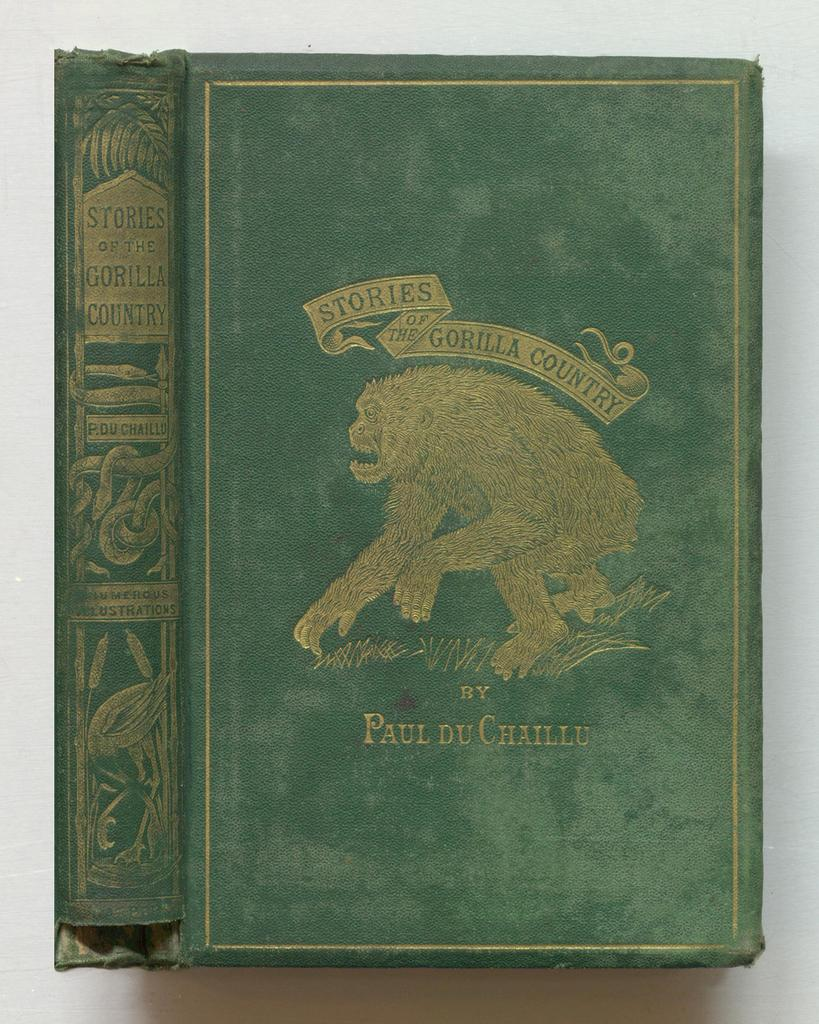<image>
Provide a brief description of the given image. Stories of the Gorilla Country features a golden gorilla on a green cover 